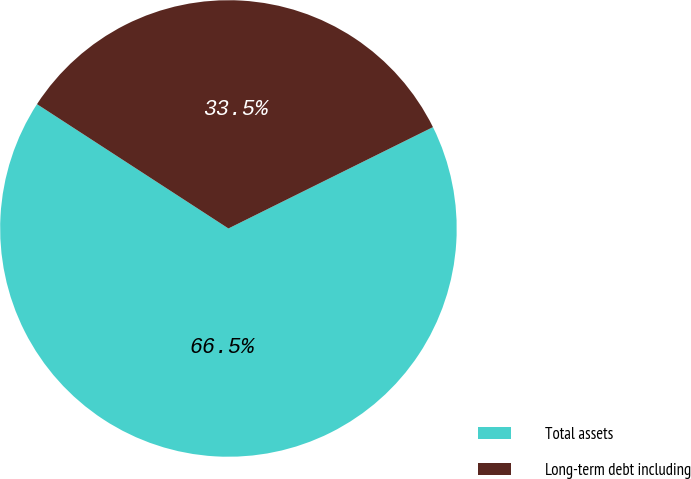Convert chart. <chart><loc_0><loc_0><loc_500><loc_500><pie_chart><fcel>Total assets<fcel>Long-term debt including<nl><fcel>66.49%<fcel>33.51%<nl></chart> 